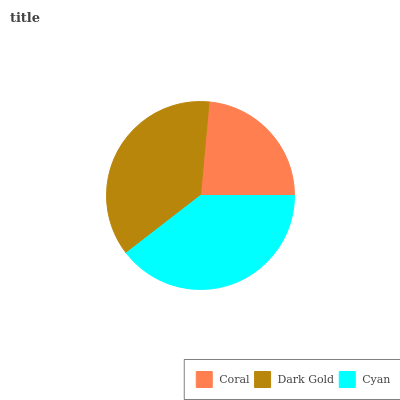Is Coral the minimum?
Answer yes or no. Yes. Is Cyan the maximum?
Answer yes or no. Yes. Is Dark Gold the minimum?
Answer yes or no. No. Is Dark Gold the maximum?
Answer yes or no. No. Is Dark Gold greater than Coral?
Answer yes or no. Yes. Is Coral less than Dark Gold?
Answer yes or no. Yes. Is Coral greater than Dark Gold?
Answer yes or no. No. Is Dark Gold less than Coral?
Answer yes or no. No. Is Dark Gold the high median?
Answer yes or no. Yes. Is Dark Gold the low median?
Answer yes or no. Yes. Is Cyan the high median?
Answer yes or no. No. Is Coral the low median?
Answer yes or no. No. 